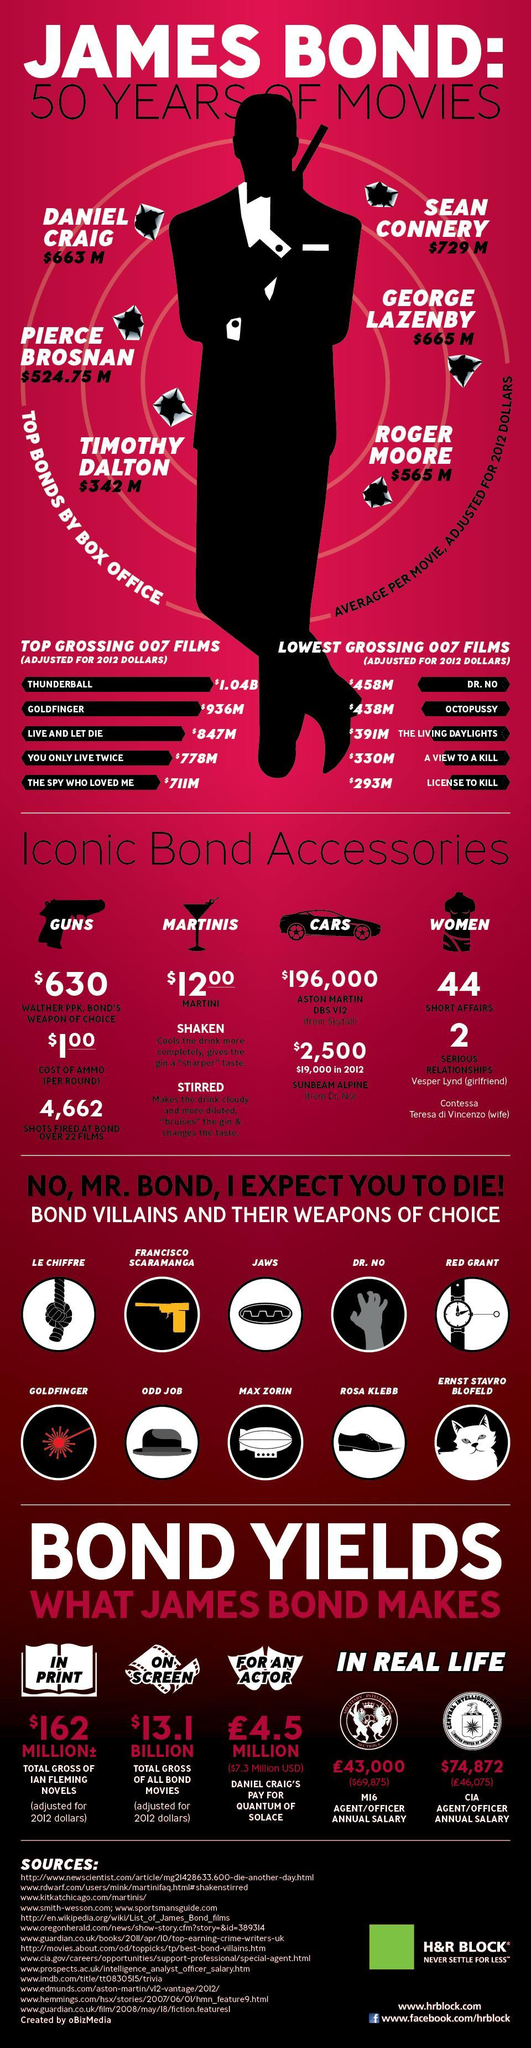Which was the lowest grossing 007 film?
Answer the question with a short phrase. license to kill Which actor as Bond scored $565M at the box office? Roger Moore Which actor as Bond earned the second most at the box office? George Lazenby Which film came in third among the lowest grossing 007 films? The living daylights Which film came in third among the top grossing 007 films? live and let die Which film came in fourth among the lowest grossing 007 films? octopussy Which film came in fifth among the top grossing 007 films? the spy who loved me Which actor as Bond came in third at the box office earnings? Daniel Craig 